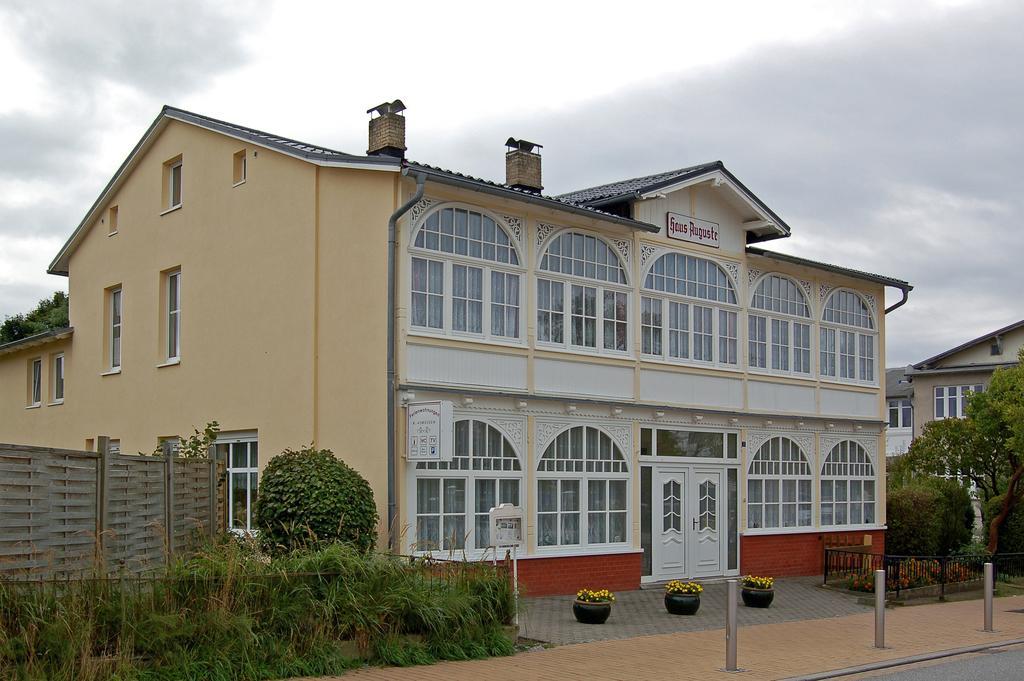Please provide a concise description of this image. In this image there is a building with the glass windows and wooden doors. At the top there is the sky. On the left side there are small plants beside the wall. On the right side there are trees in front of the buildings. 